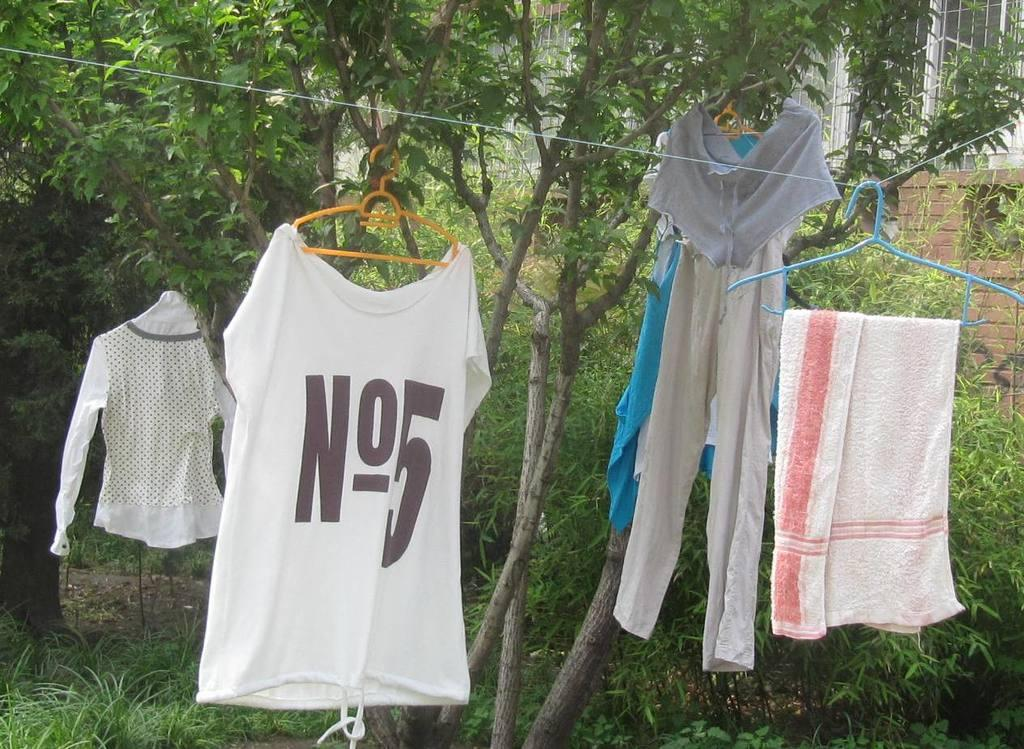<image>
Present a compact description of the photo's key features. Clothes hanging outdoors with a shirt saying No.5 